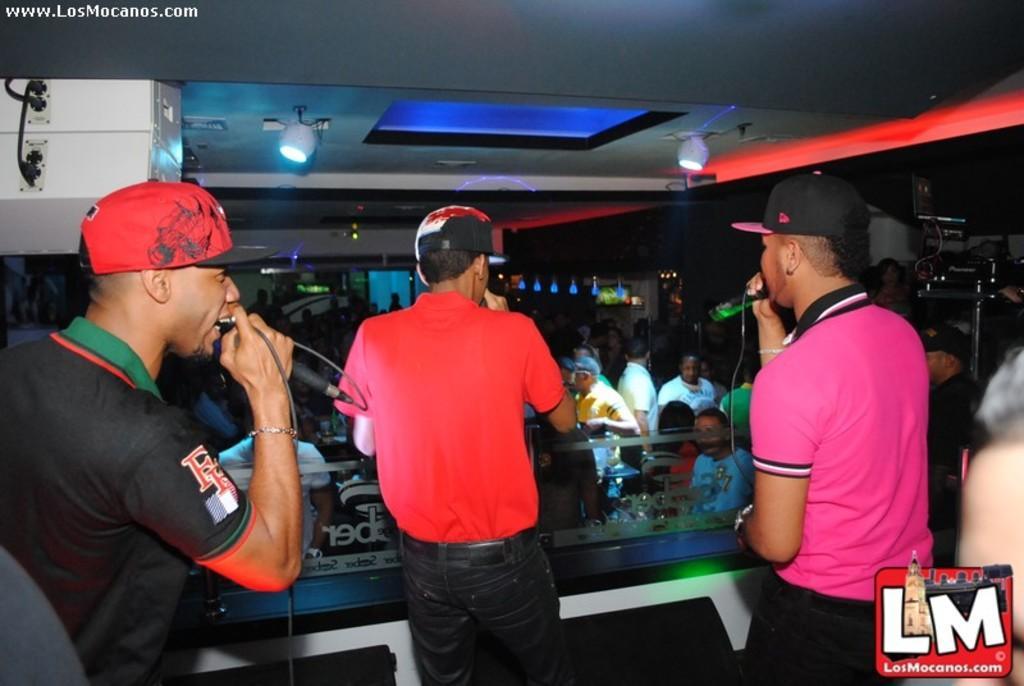Can you describe this image briefly? In this image we can see people standing and holding mics. There is crowd. At the top there are lights. In the background there is a door and we can see walls. 